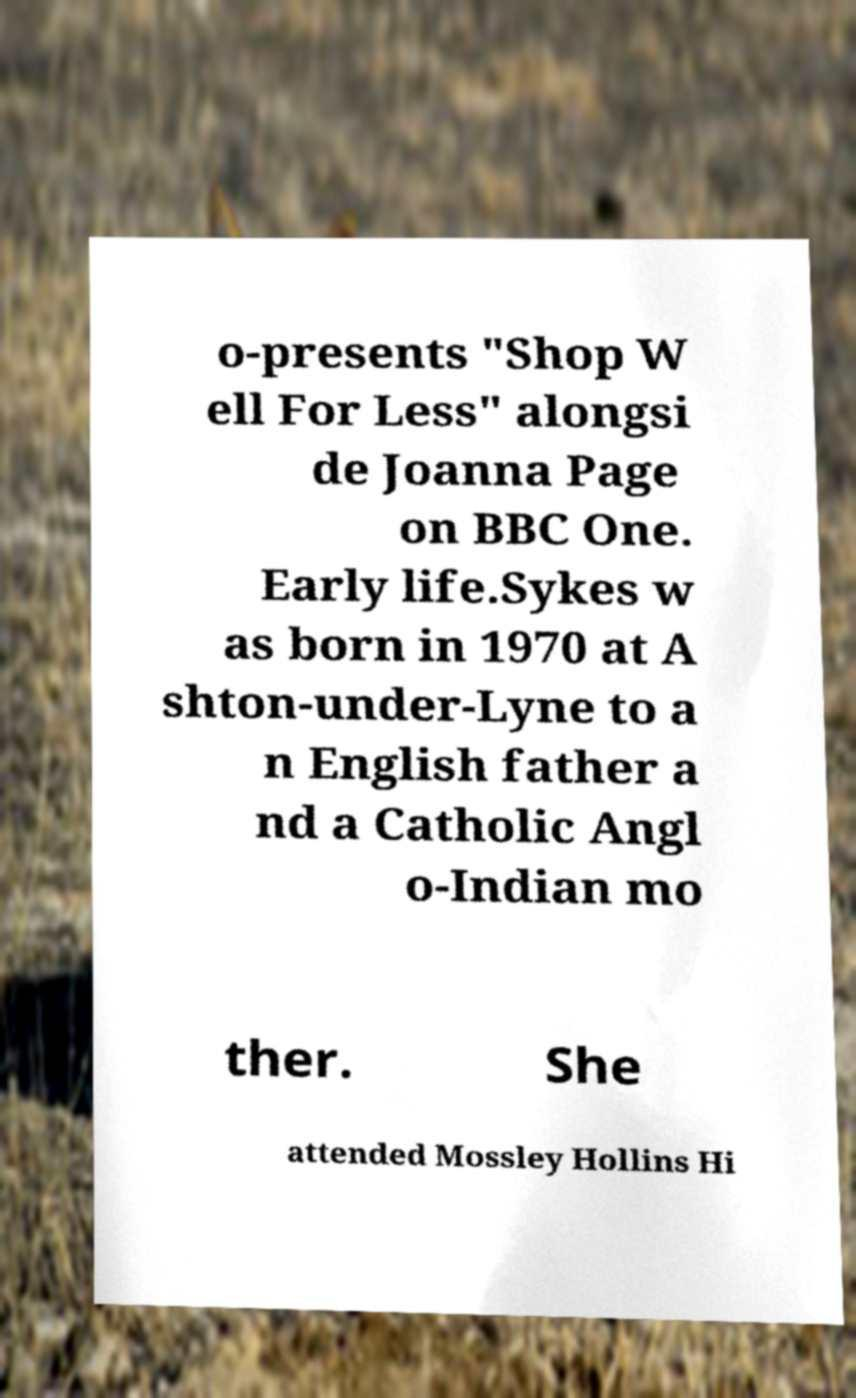Could you assist in decoding the text presented in this image and type it out clearly? o-presents "Shop W ell For Less" alongsi de Joanna Page on BBC One. Early life.Sykes w as born in 1970 at A shton-under-Lyne to a n English father a nd a Catholic Angl o-Indian mo ther. She attended Mossley Hollins Hi 